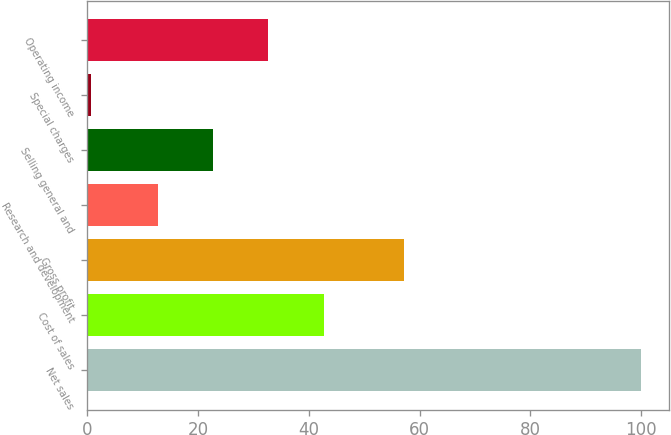<chart> <loc_0><loc_0><loc_500><loc_500><bar_chart><fcel>Net sales<fcel>Cost of sales<fcel>Gross profit<fcel>Research and development<fcel>Selling general and<fcel>Special charges<fcel>Operating income<nl><fcel>100<fcel>42.8<fcel>57.2<fcel>12.8<fcel>22.73<fcel>0.7<fcel>32.66<nl></chart> 